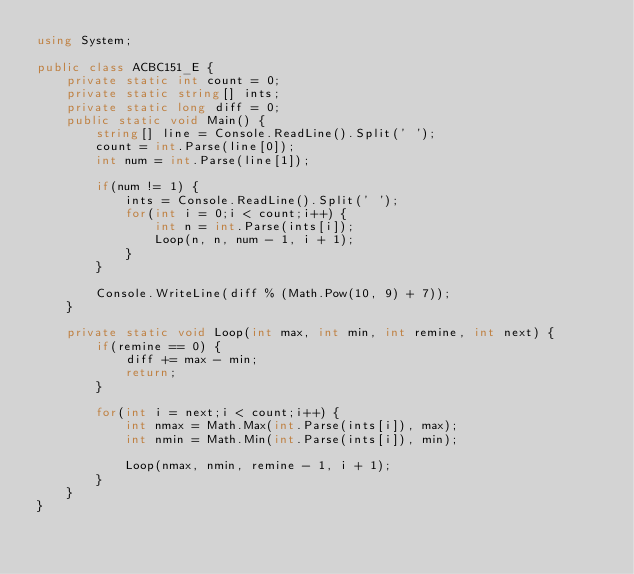Convert code to text. <code><loc_0><loc_0><loc_500><loc_500><_C#_>using System;

public class ACBC151_E {
    private static int count = 0;
    private static string[] ints;
    private static long diff = 0;
    public static void Main() {
        string[] line = Console.ReadLine().Split(' ');
        count = int.Parse(line[0]);
        int num = int.Parse(line[1]);

        if(num != 1) {
            ints = Console.ReadLine().Split(' ');
            for(int i = 0;i < count;i++) {
                int n = int.Parse(ints[i]);
                Loop(n, n, num - 1, i + 1);
            }
        }

        Console.WriteLine(diff % (Math.Pow(10, 9) + 7));
    }

    private static void Loop(int max, int min, int remine, int next) {
        if(remine == 0) {
            diff += max - min;
            return;
        }

        for(int i = next;i < count;i++) {
            int nmax = Math.Max(int.Parse(ints[i]), max);
            int nmin = Math.Min(int.Parse(ints[i]), min);
            
            Loop(nmax, nmin, remine - 1, i + 1);
        }
    }
}</code> 